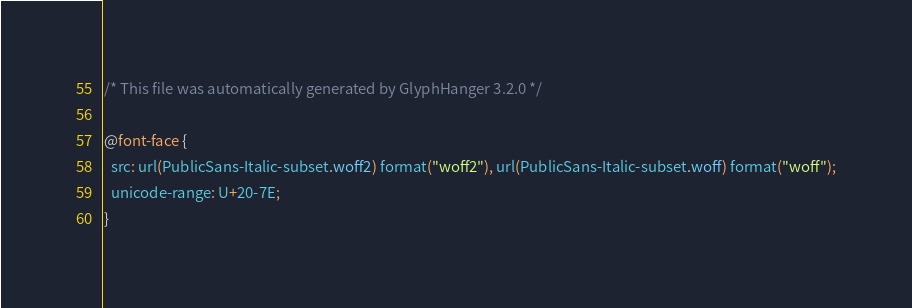Convert code to text. <code><loc_0><loc_0><loc_500><loc_500><_CSS_>/* This file was automatically generated by GlyphHanger 3.2.0 */

@font-face {
  src: url(PublicSans-Italic-subset.woff2) format("woff2"), url(PublicSans-Italic-subset.woff) format("woff");
  unicode-range: U+20-7E;
}</code> 